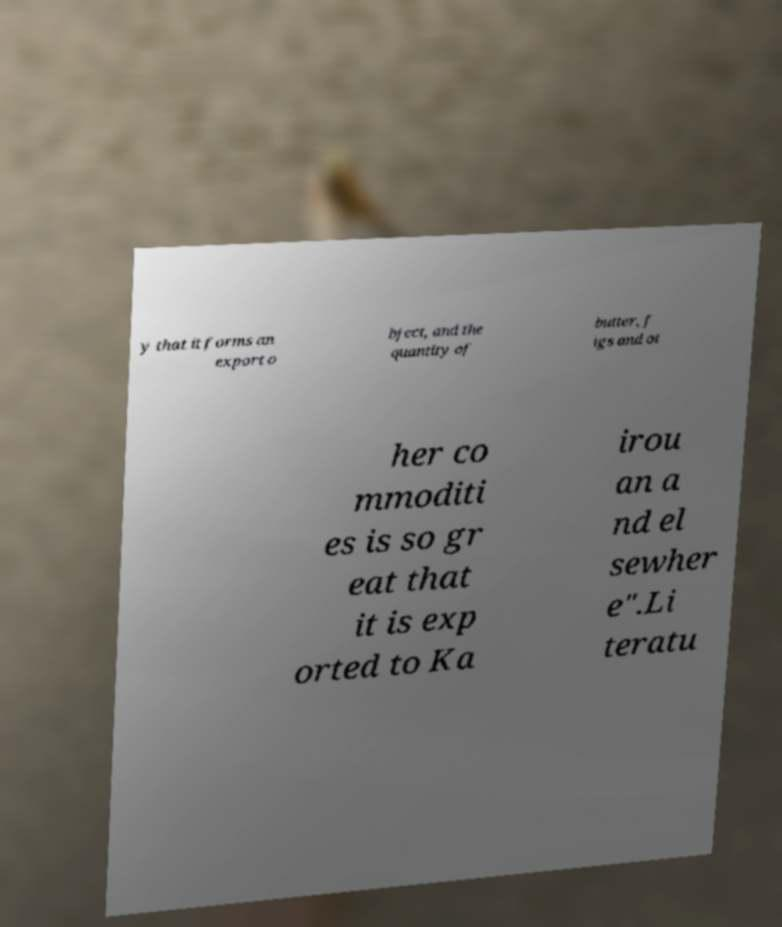What messages or text are displayed in this image? I need them in a readable, typed format. y that it forms an export o bject, and the quantity of butter, f igs and ot her co mmoditi es is so gr eat that it is exp orted to Ka irou an a nd el sewher e".Li teratu 